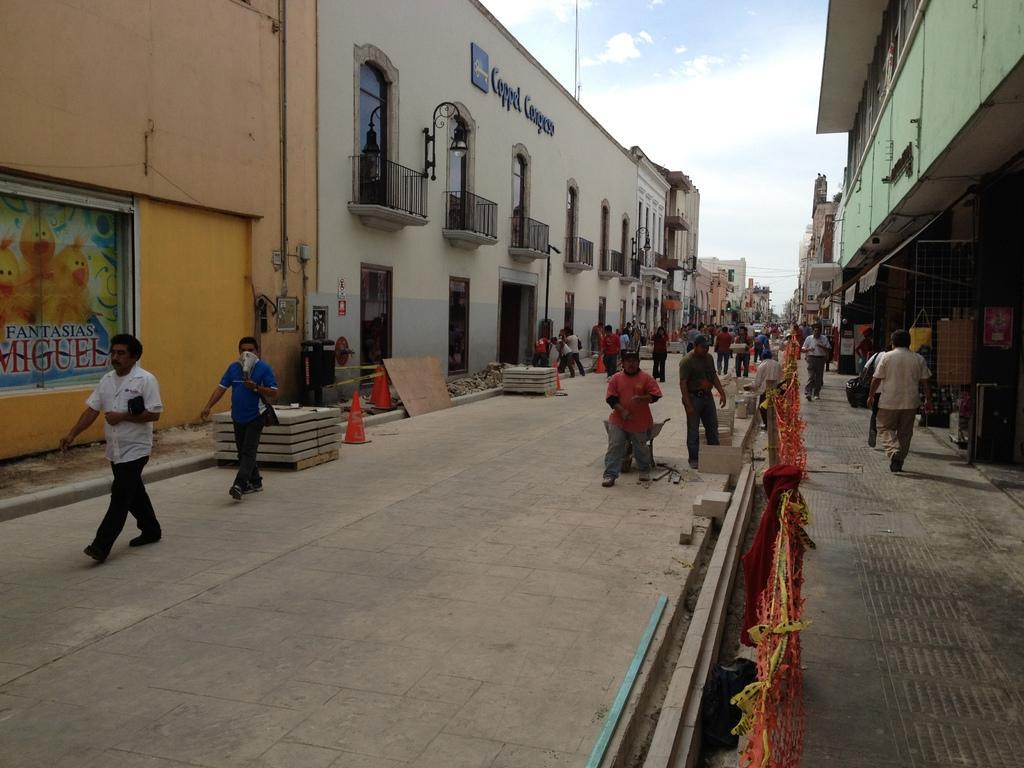Describe this image in one or two sentences. This picture is clicked outside. On both the sides we can see the buildings and we can see the group of persons seems to be walking on the ground and we can see the safety cones and some other objects are placed on the ground and we can see the text and some pictures on the buildings and we can see the windows, railings, lamppost and in the background we can see the sky and many other objects. 